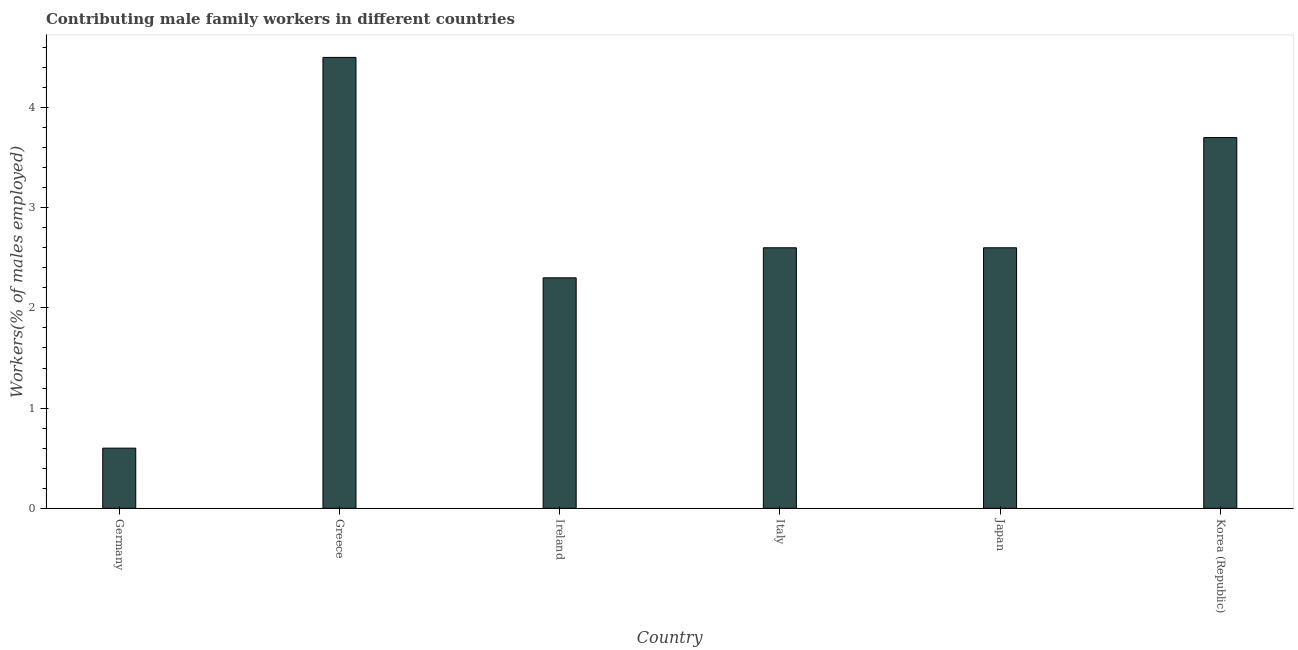Does the graph contain any zero values?
Your answer should be compact. No. What is the title of the graph?
Provide a short and direct response. Contributing male family workers in different countries. What is the label or title of the Y-axis?
Your response must be concise. Workers(% of males employed). What is the contributing male family workers in Germany?
Your answer should be very brief. 0.6. Across all countries, what is the minimum contributing male family workers?
Offer a terse response. 0.6. What is the sum of the contributing male family workers?
Your response must be concise. 16.3. What is the difference between the contributing male family workers in Greece and Korea (Republic)?
Your response must be concise. 0.8. What is the average contributing male family workers per country?
Provide a succinct answer. 2.72. What is the median contributing male family workers?
Ensure brevity in your answer.  2.6. What is the ratio of the contributing male family workers in Ireland to that in Korea (Republic)?
Provide a succinct answer. 0.62. Is the difference between the contributing male family workers in Italy and Japan greater than the difference between any two countries?
Keep it short and to the point. No. What is the difference between the highest and the second highest contributing male family workers?
Provide a short and direct response. 0.8. In how many countries, is the contributing male family workers greater than the average contributing male family workers taken over all countries?
Give a very brief answer. 2. How many countries are there in the graph?
Keep it short and to the point. 6. What is the Workers(% of males employed) of Germany?
Offer a terse response. 0.6. What is the Workers(% of males employed) of Greece?
Provide a short and direct response. 4.5. What is the Workers(% of males employed) in Ireland?
Make the answer very short. 2.3. What is the Workers(% of males employed) in Italy?
Your answer should be compact. 2.6. What is the Workers(% of males employed) of Japan?
Keep it short and to the point. 2.6. What is the Workers(% of males employed) in Korea (Republic)?
Your answer should be compact. 3.7. What is the difference between the Workers(% of males employed) in Germany and Japan?
Offer a very short reply. -2. What is the difference between the Workers(% of males employed) in Germany and Korea (Republic)?
Your answer should be compact. -3.1. What is the difference between the Workers(% of males employed) in Greece and Italy?
Offer a terse response. 1.9. What is the difference between the Workers(% of males employed) in Italy and Japan?
Your response must be concise. 0. What is the difference between the Workers(% of males employed) in Italy and Korea (Republic)?
Your answer should be compact. -1.1. What is the ratio of the Workers(% of males employed) in Germany to that in Greece?
Ensure brevity in your answer.  0.13. What is the ratio of the Workers(% of males employed) in Germany to that in Ireland?
Provide a succinct answer. 0.26. What is the ratio of the Workers(% of males employed) in Germany to that in Italy?
Offer a terse response. 0.23. What is the ratio of the Workers(% of males employed) in Germany to that in Japan?
Your response must be concise. 0.23. What is the ratio of the Workers(% of males employed) in Germany to that in Korea (Republic)?
Keep it short and to the point. 0.16. What is the ratio of the Workers(% of males employed) in Greece to that in Ireland?
Your answer should be very brief. 1.96. What is the ratio of the Workers(% of males employed) in Greece to that in Italy?
Your answer should be very brief. 1.73. What is the ratio of the Workers(% of males employed) in Greece to that in Japan?
Provide a succinct answer. 1.73. What is the ratio of the Workers(% of males employed) in Greece to that in Korea (Republic)?
Your answer should be compact. 1.22. What is the ratio of the Workers(% of males employed) in Ireland to that in Italy?
Provide a succinct answer. 0.89. What is the ratio of the Workers(% of males employed) in Ireland to that in Japan?
Provide a succinct answer. 0.89. What is the ratio of the Workers(% of males employed) in Ireland to that in Korea (Republic)?
Your answer should be compact. 0.62. What is the ratio of the Workers(% of males employed) in Italy to that in Korea (Republic)?
Give a very brief answer. 0.7. What is the ratio of the Workers(% of males employed) in Japan to that in Korea (Republic)?
Provide a succinct answer. 0.7. 